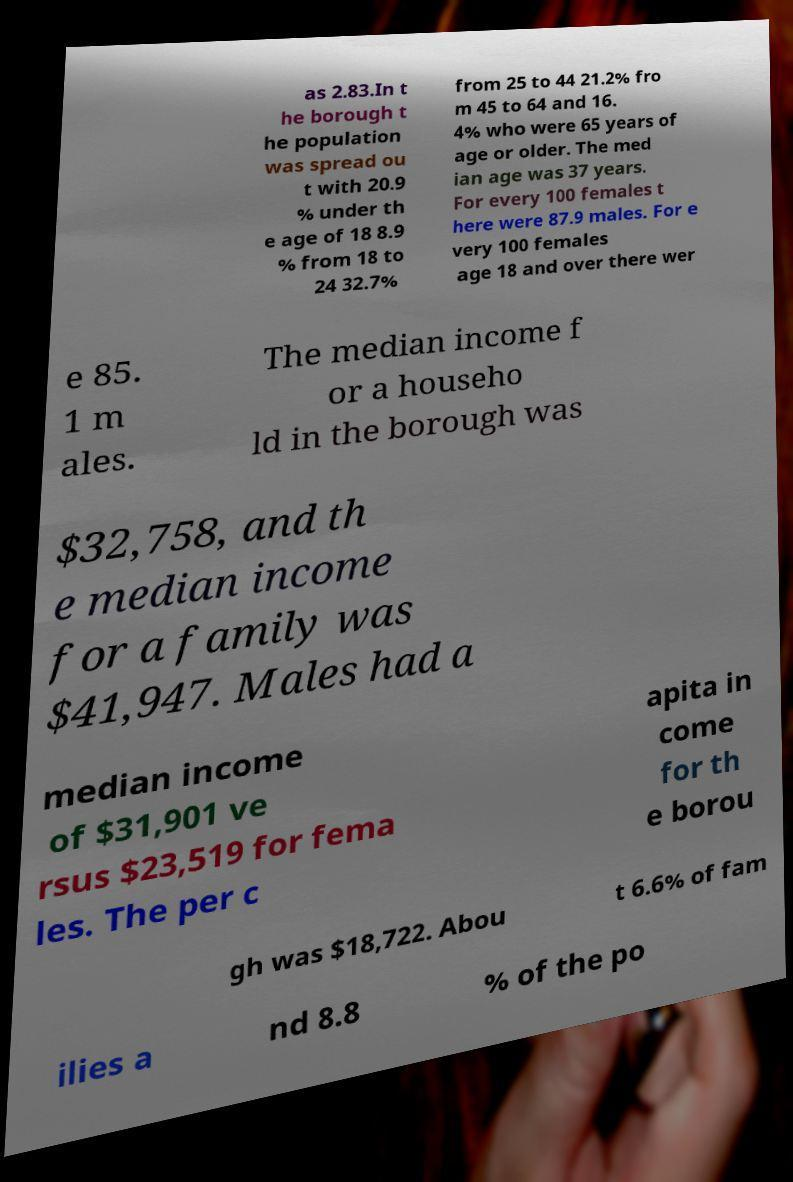Please identify and transcribe the text found in this image. as 2.83.In t he borough t he population was spread ou t with 20.9 % under th e age of 18 8.9 % from 18 to 24 32.7% from 25 to 44 21.2% fro m 45 to 64 and 16. 4% who were 65 years of age or older. The med ian age was 37 years. For every 100 females t here were 87.9 males. For e very 100 females age 18 and over there wer e 85. 1 m ales. The median income f or a househo ld in the borough was $32,758, and th e median income for a family was $41,947. Males had a median income of $31,901 ve rsus $23,519 for fema les. The per c apita in come for th e borou gh was $18,722. Abou t 6.6% of fam ilies a nd 8.8 % of the po 